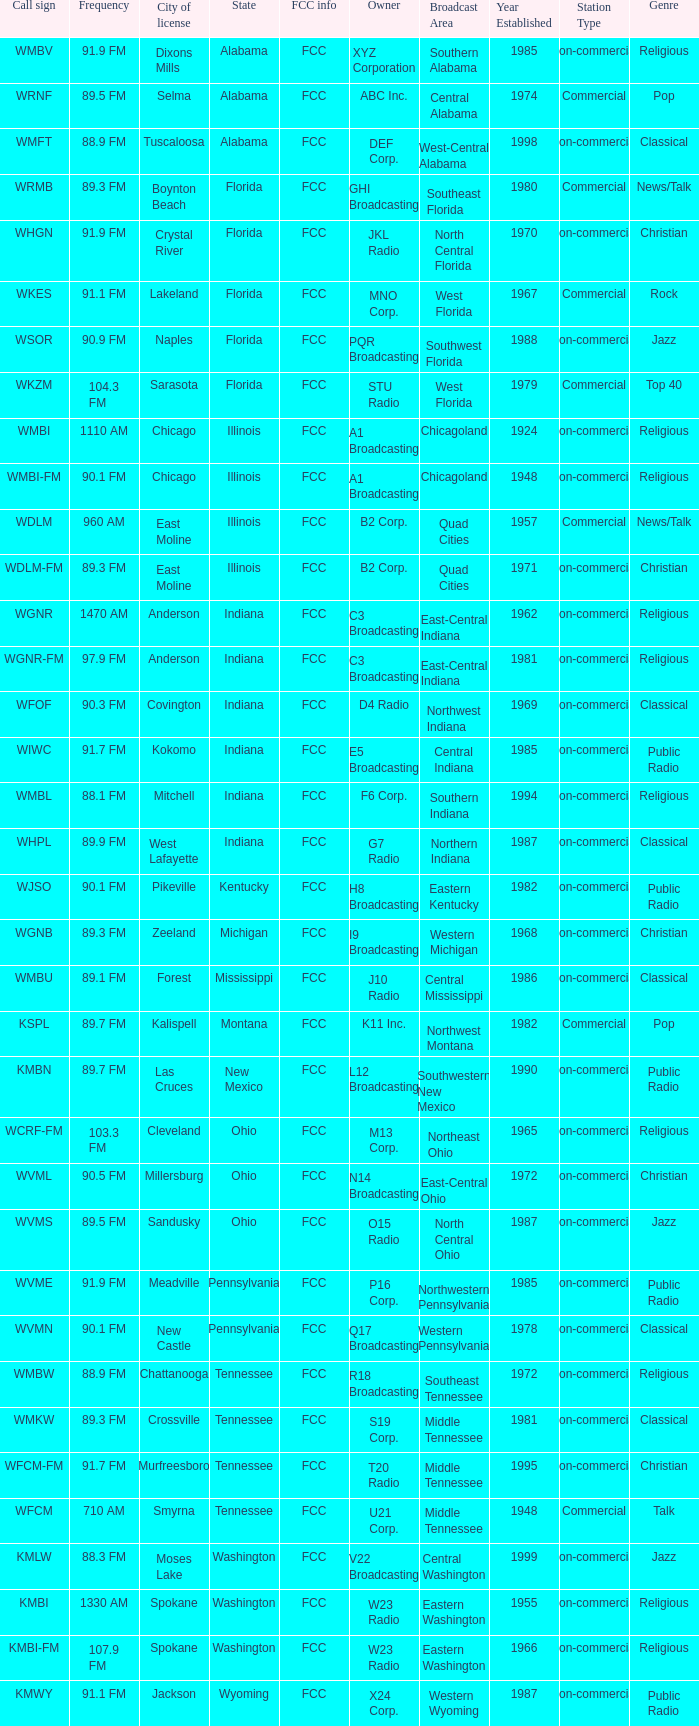What is the FCC info for the radio station in West Lafayette, Indiana? FCC. 